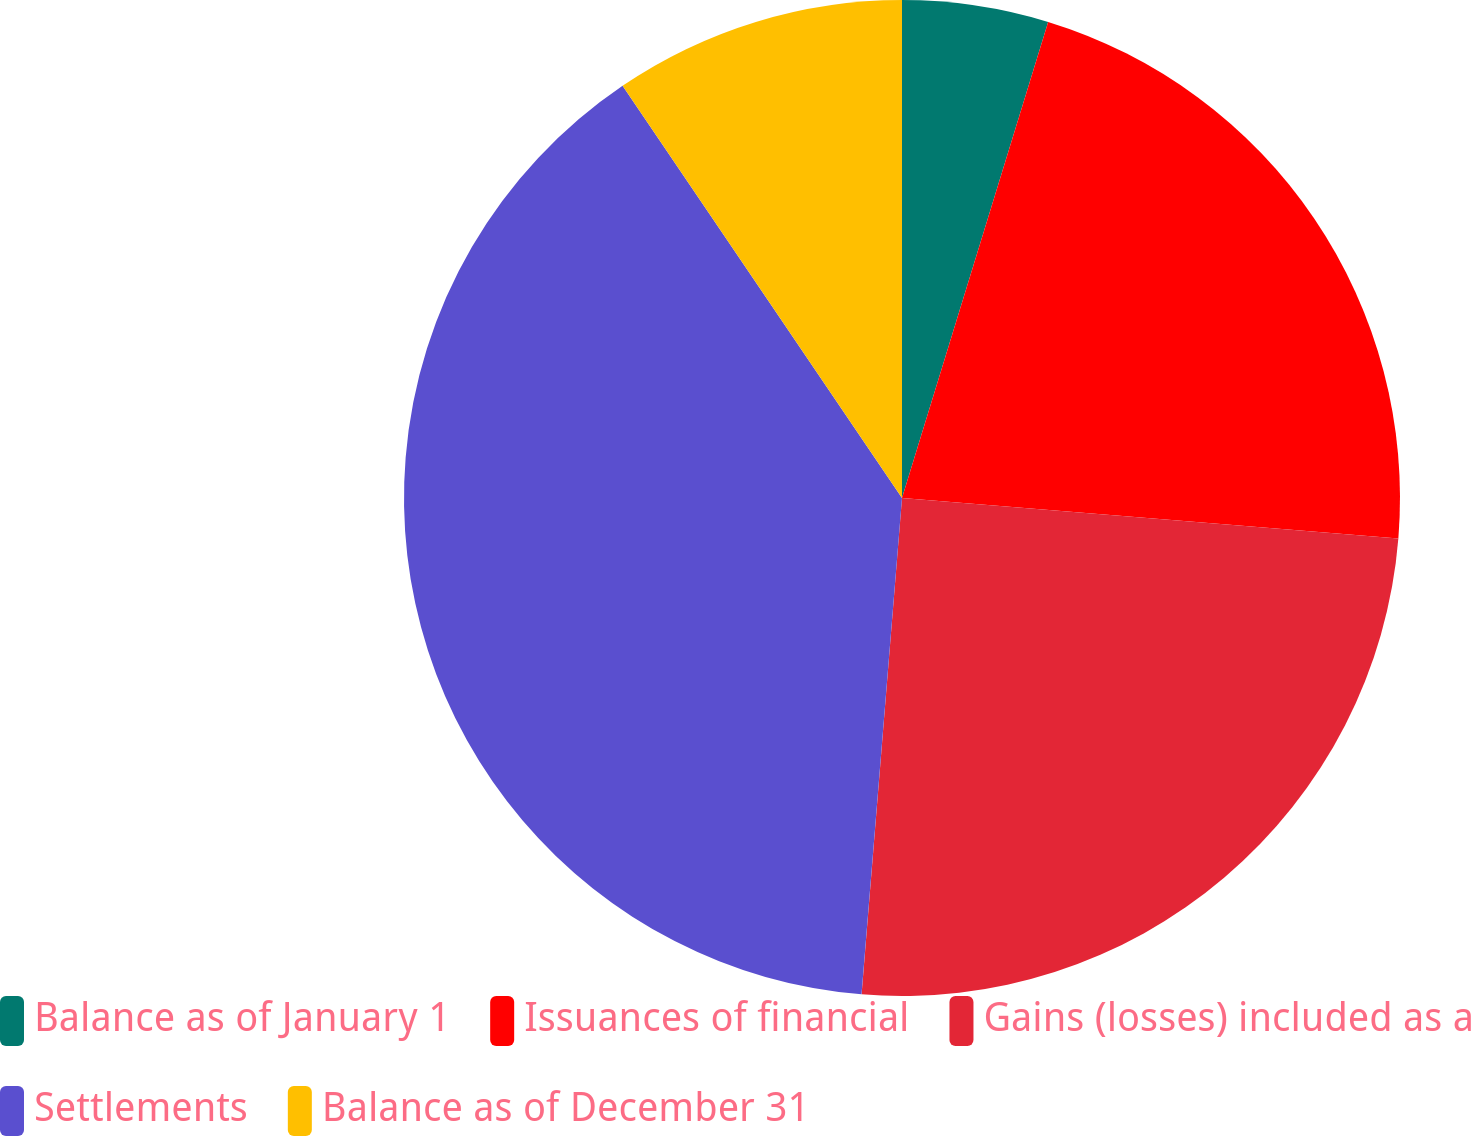Convert chart to OTSL. <chart><loc_0><loc_0><loc_500><loc_500><pie_chart><fcel>Balance as of January 1<fcel>Issuances of financial<fcel>Gains (losses) included as a<fcel>Settlements<fcel>Balance as of December 31<nl><fcel>4.74%<fcel>21.55%<fcel>25.0%<fcel>39.22%<fcel>9.48%<nl></chart> 